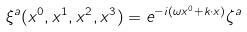<formula> <loc_0><loc_0><loc_500><loc_500>\xi ^ { a } ( x ^ { 0 } , x ^ { 1 } , x ^ { 2 } , x ^ { 3 } ) = e ^ { - i ( \omega x ^ { 0 } + k \cdot x ) } \zeta ^ { a }</formula> 